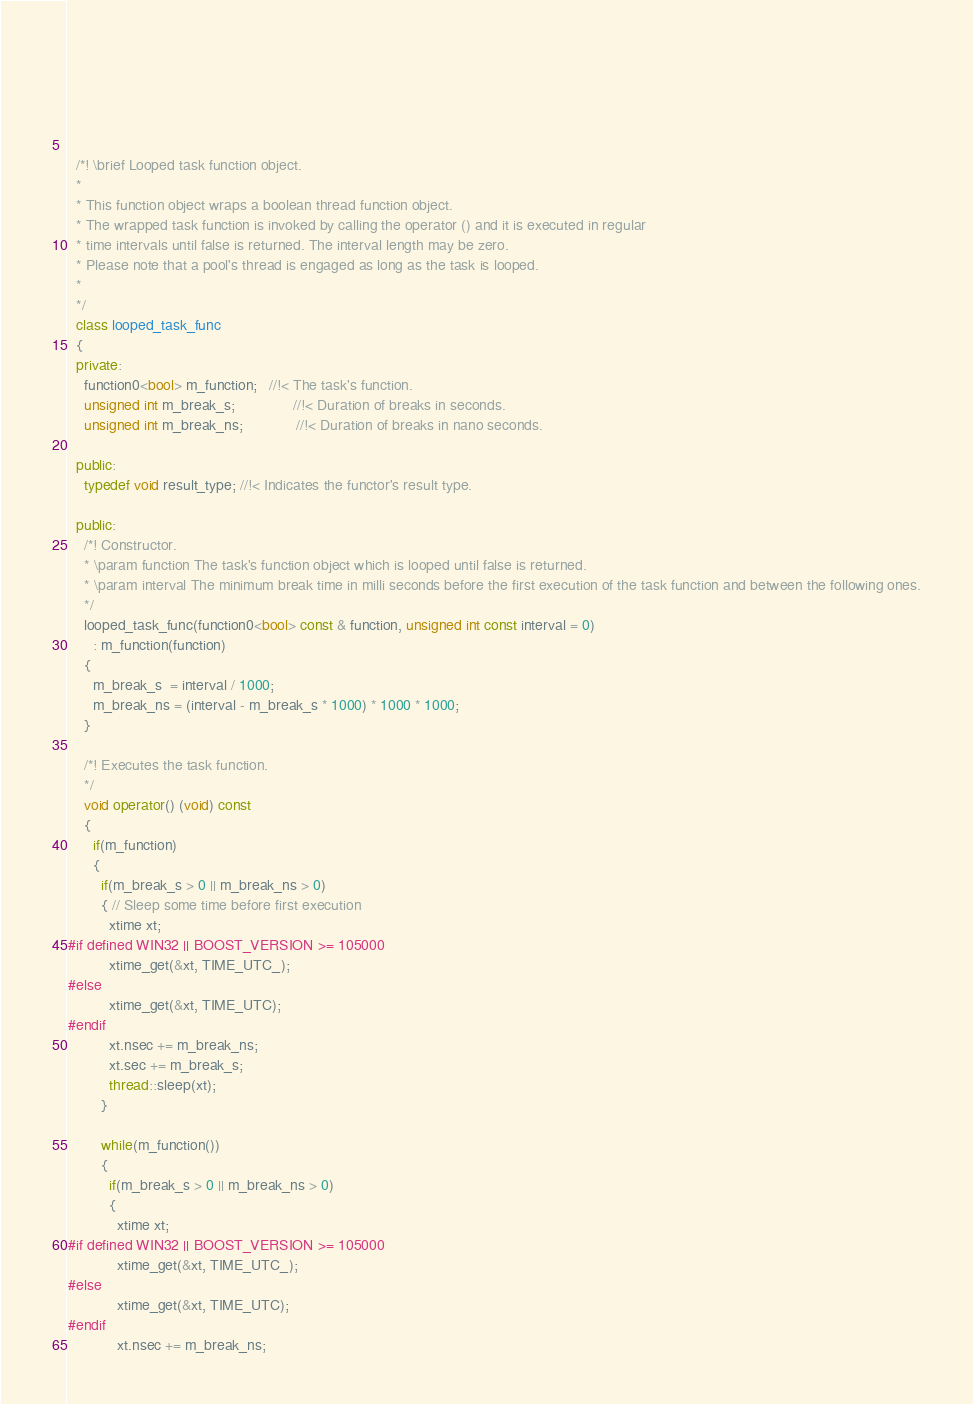Convert code to text. <code><loc_0><loc_0><loc_500><loc_500><_C++_>


 




  /*! \brief Looped task function object. 
  *
  * This function object wraps a boolean thread function object.
  * The wrapped task function is invoked by calling the operator () and it is executed in regular 
  * time intervals until false is returned. The interval length may be zero.
  * Please note that a pool's thread is engaged as long as the task is looped.
  *
  */ 
  class looped_task_func
  {
  private:
    function0<bool> m_function;   //!< The task's function.
    unsigned int m_break_s;              //!< Duration of breaks in seconds.
    unsigned int m_break_ns;             //!< Duration of breaks in nano seconds.

  public:
    typedef void result_type; //!< Indicates the functor's result type.

  public:
    /*! Constructor.
    * \param function The task's function object which is looped until false is returned.
    * \param interval The minimum break time in milli seconds before the first execution of the task function and between the following ones.
    */
    looped_task_func(function0<bool> const & function, unsigned int const interval = 0)
      : m_function(function)
    {
      m_break_s  = interval / 1000;
      m_break_ns = (interval - m_break_s * 1000) * 1000 * 1000;
    }

    /*! Executes the task function.
    */
    void operator() (void) const
    {
      if(m_function)
      {
        if(m_break_s > 0 || m_break_ns > 0)
        { // Sleep some time before first execution
          xtime xt;
#if defined WIN32 || BOOST_VERSION >= 105000
          xtime_get(&xt, TIME_UTC_);
#else
          xtime_get(&xt, TIME_UTC);
#endif
          xt.nsec += m_break_ns;
          xt.sec += m_break_s;
          thread::sleep(xt); 
        }

        while(m_function())
        {
          if(m_break_s > 0 || m_break_ns > 0)
          {
            xtime xt;
#if defined WIN32 || BOOST_VERSION >= 105000
            xtime_get(&xt, TIME_UTC_);
#else
            xtime_get(&xt, TIME_UTC);
#endif
            xt.nsec += m_break_ns;</code> 